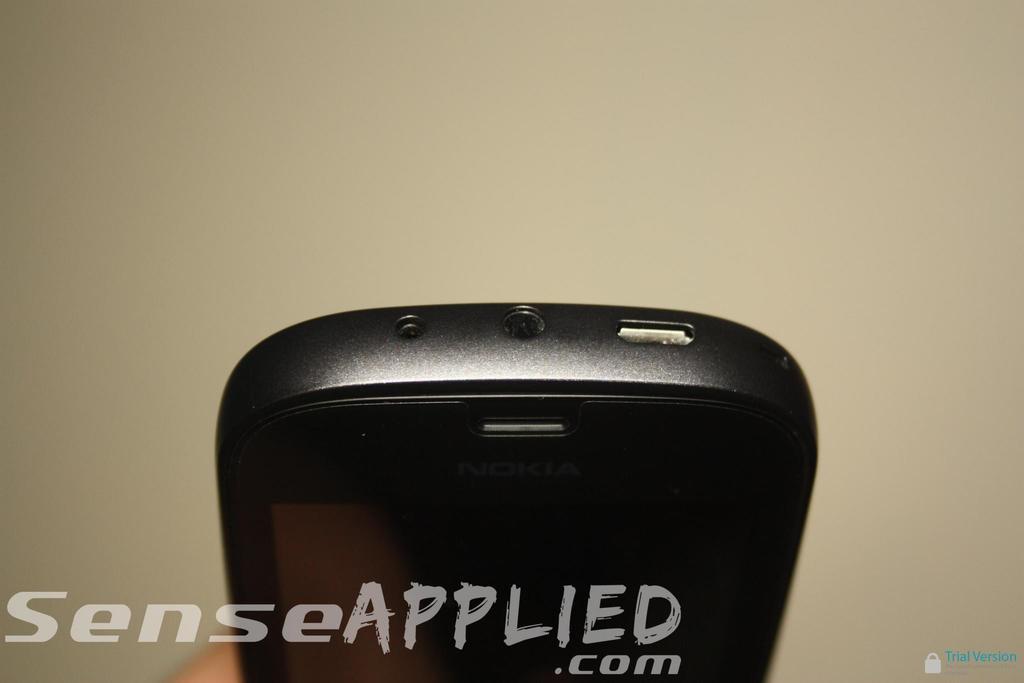What brand of phone is this?
Give a very brief answer. Nokia. Whats the phone type?
Your response must be concise. Unanswerable. 